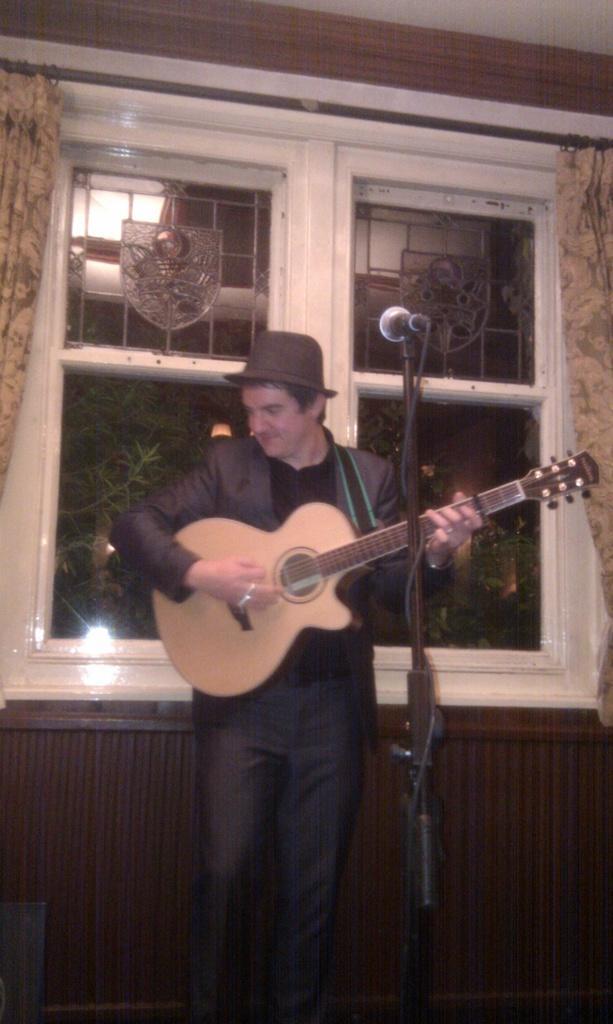Could you give a brief overview of what you see in this image? In the image we can see there is a person who is standing and holding guitar in his hand and in front of him there is a mic with a stand and the person is wearing cap and formal suit and behind him there is a window and there are curtains. 